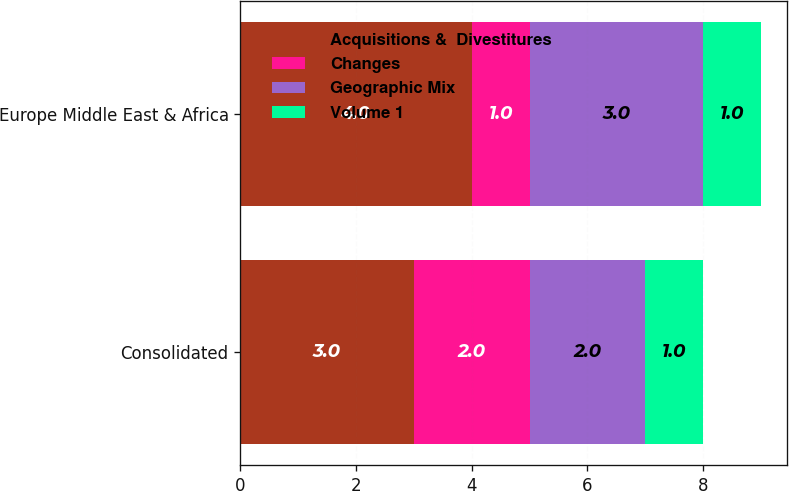Convert chart to OTSL. <chart><loc_0><loc_0><loc_500><loc_500><stacked_bar_chart><ecel><fcel>Consolidated<fcel>Europe Middle East & Africa<nl><fcel>Acquisitions &  Divestitures<fcel>3<fcel>4<nl><fcel>Changes<fcel>2<fcel>1<nl><fcel>Geographic Mix<fcel>2<fcel>3<nl><fcel>Volume 1<fcel>1<fcel>1<nl></chart> 